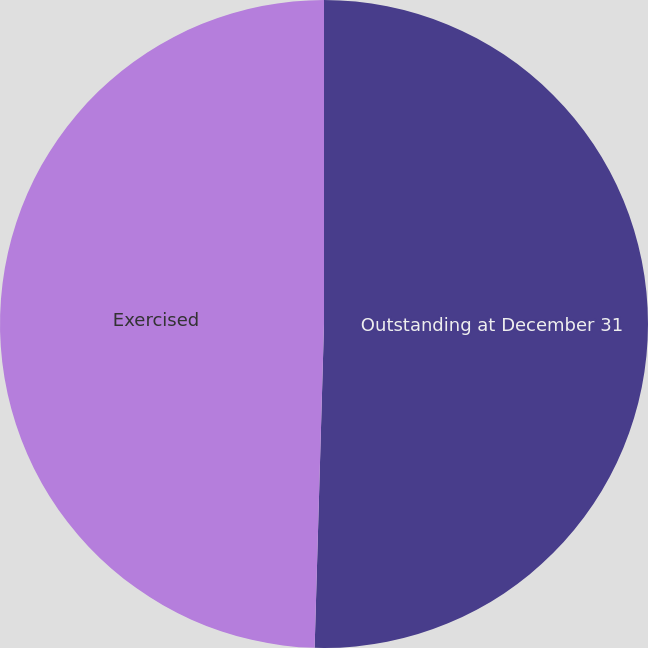Convert chart to OTSL. <chart><loc_0><loc_0><loc_500><loc_500><pie_chart><fcel>Outstanding at December 31<fcel>Exercised<nl><fcel>50.46%<fcel>49.54%<nl></chart> 